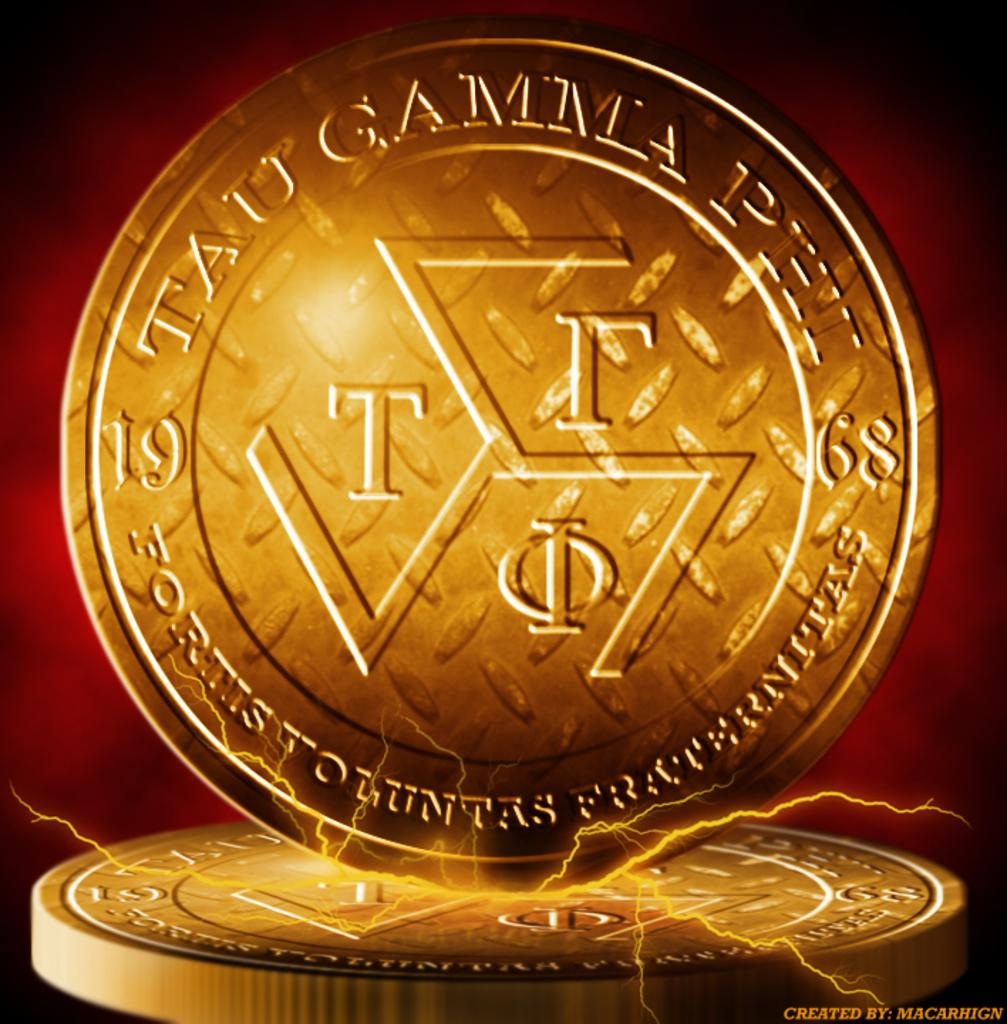<image>
Relay a brief, clear account of the picture shown. A medal says Tau Gamma Phi, 1968 and sits on top of another. 